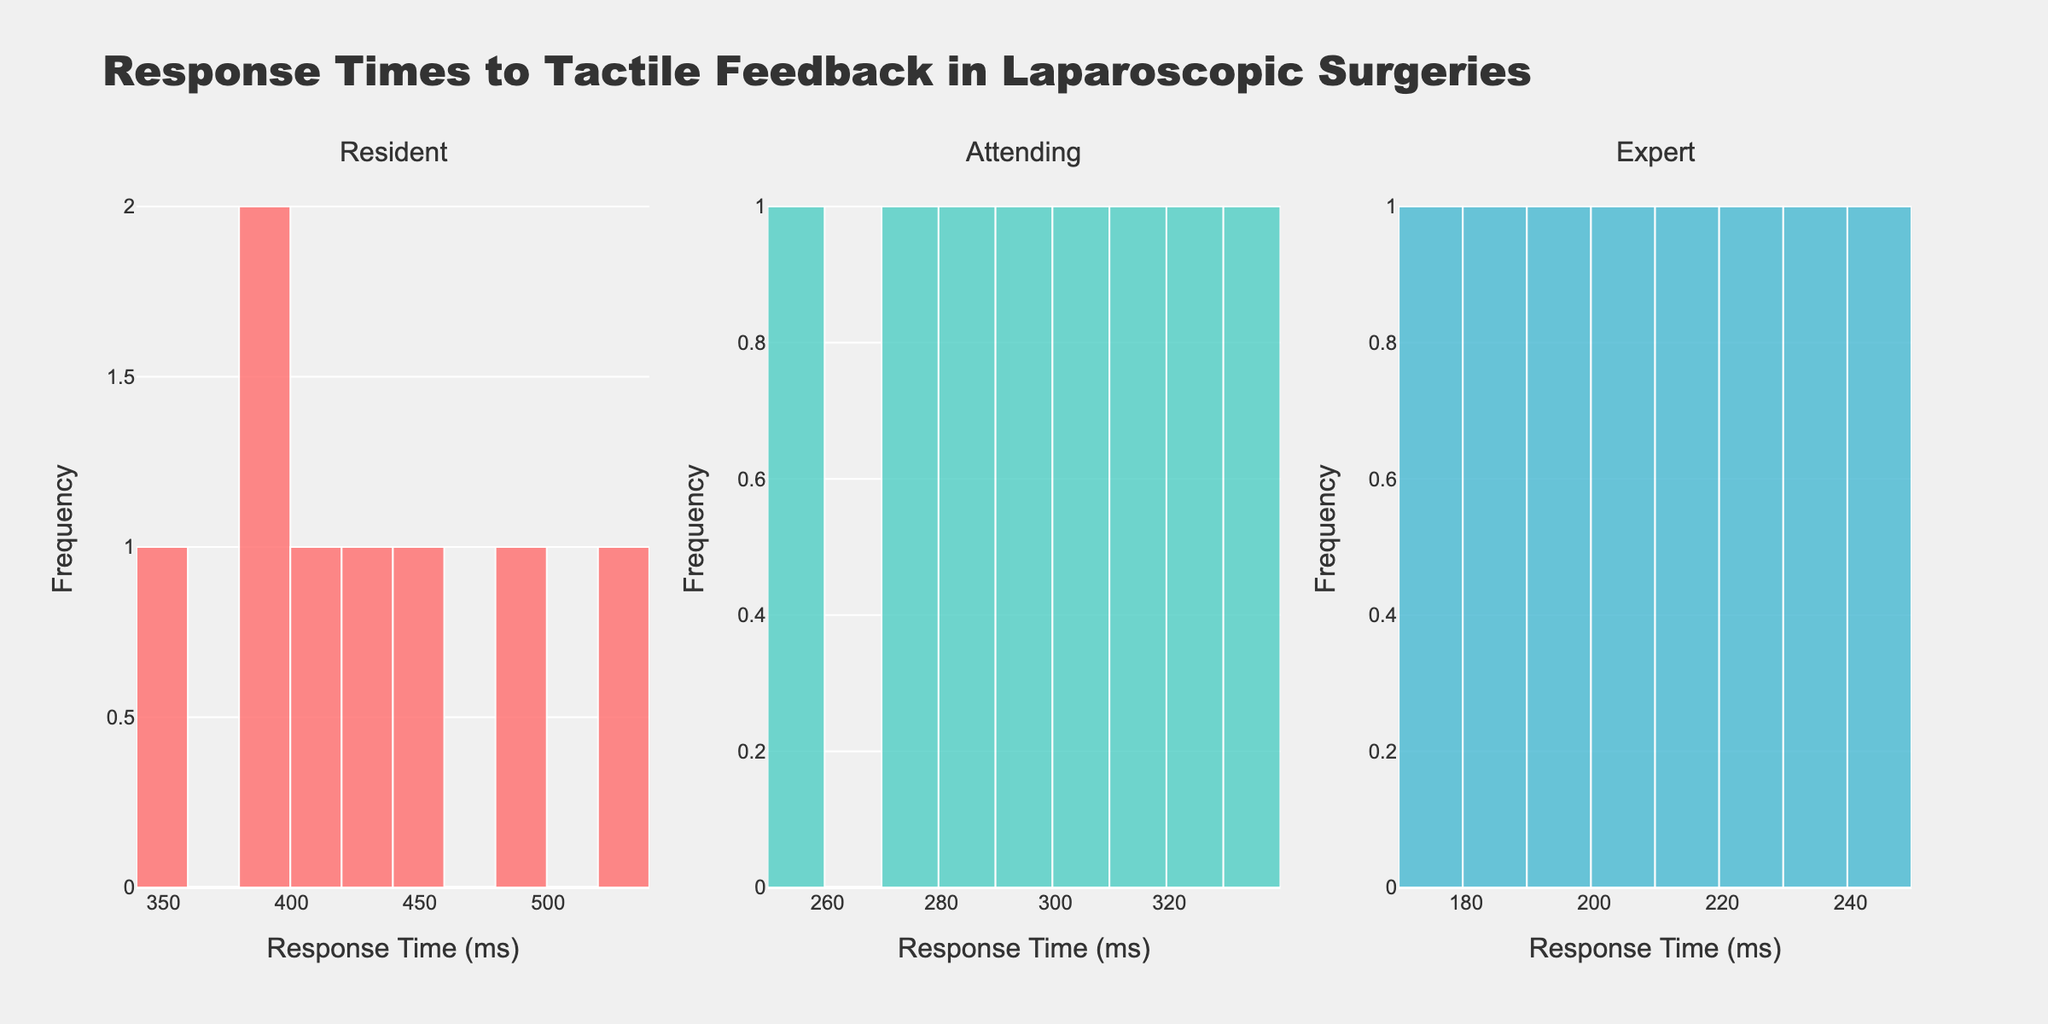What is the title of the figure? The title of the figure is typically displayed at the top and summarizes the content of the chart.
Answer: Response Times to Tactile Feedback in Laparoscopic Surgeries What colors are used to represent each experience level? The subplots use distinct colors to visually differentiate the groups. The colors are: Resident in red, Attending in green, and Expert in blue.
Answer: Red, Green, Blue How many subplots are there in the figure? The figure is divided into sections for different experience levels, resulting in multiple subplots. By counting these sections, we find there are 3 subplots.
Answer: 3 Which experience level shows the fastest response times overall? By examining the histogram distributions, the subplots for each experience level reveal the data spread. The Expert level exhibits response times concentrated in lower values, indicating faster reactions.
Answer: Expert What is the range of response times for the Residents? The range of a dataset is found by subtracting the lowest value from the highest value. In the Resident subplot, the highest response time is 520 ms and the lowest is 350 ms, giving us 520 - 350 = 170 ms.
Answer: 170 ms Which subplot has the highest peak in frequency? The height of the bars in histograms indicates frequency. By comparing the peaks, it is evident that the Attending subplot has the highest bar.
Answer: Attending What is the average response time for the Attending group? To calculate the average, add all the response times from the Attending group and divide by the number of data points. (280 + 310 + 250 + 330 + 290 + 270 + 300 + 320) / 8 = 287.5 ms
Answer: 287.5 ms How does the frequency distribution of the Resident group compare to the Expert group? By comparing the histograms of these groups, we notice that the Resident group has a broader and more spread out distribution, whereas the Expert group's distribution is narrower, suggesting more consistent response times.
Answer: Resident: Broader spread; Expert: Narrower spread What is the longest recorded response time in the dataset and which group does it belong to? Identifying the highest bar on the x-axis scales across all subplots shows the maximum value. The Resident group has the longest response time recorded at 520 ms.
Answer: Resident, 520 ms Which experience level shows more variability in response times? Variability can often be observed by the spread of bars in the histogram. The Resident group has a wider spread of response times compared to Attending and Expert, indicating more variability.
Answer: Resident 